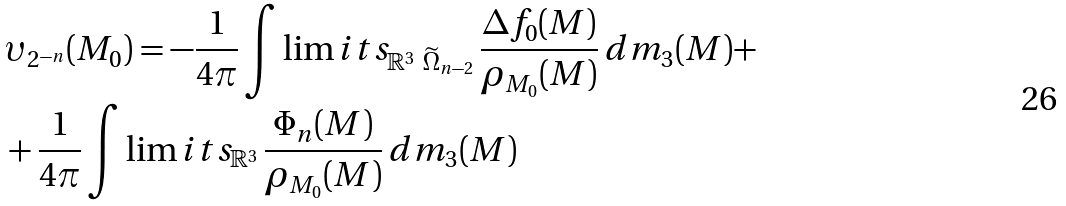Convert formula to latex. <formula><loc_0><loc_0><loc_500><loc_500>& \upsilon _ { 2 ^ { - n } } ( M _ { 0 } ) = - \frac { 1 } { 4 \pi } \int \lim i t s _ { \mathbb { R } ^ { 3 } \ \widetilde { \Omega } _ { n - 2 } } \, \frac { \Delta f _ { 0 } ( M ) } { \rho _ { M _ { 0 } } ( M ) } \, d m _ { 3 } ( M ) + \\ & + \frac { 1 } { 4 \pi } \int \lim i t s _ { \mathbb { R } ^ { 3 } } \, \frac { \Phi _ { n } ( M ) } { \rho _ { M _ { 0 } } ( M ) } \, d m _ { 3 } ( M )</formula> 